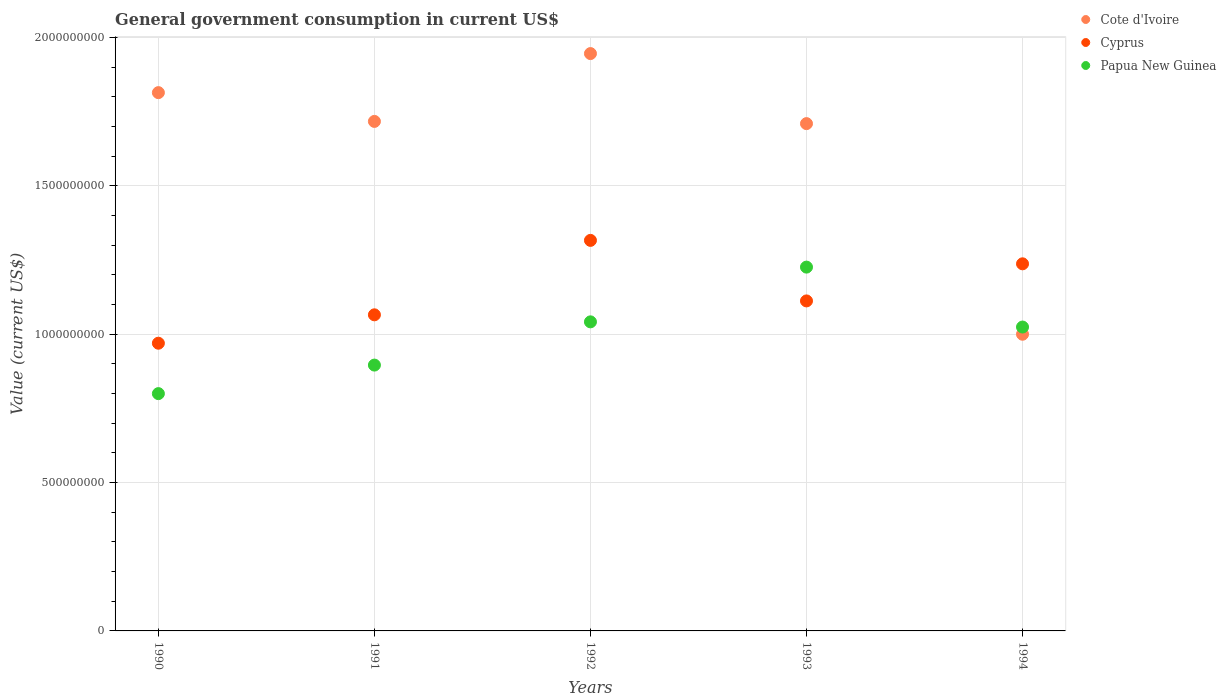How many different coloured dotlines are there?
Ensure brevity in your answer.  3. Is the number of dotlines equal to the number of legend labels?
Offer a terse response. Yes. What is the government conusmption in Papua New Guinea in 1991?
Provide a short and direct response. 8.96e+08. Across all years, what is the maximum government conusmption in Papua New Guinea?
Keep it short and to the point. 1.23e+09. Across all years, what is the minimum government conusmption in Cyprus?
Make the answer very short. 9.69e+08. What is the total government conusmption in Cote d'Ivoire in the graph?
Keep it short and to the point. 8.18e+09. What is the difference between the government conusmption in Cyprus in 1993 and that in 1994?
Your response must be concise. -1.25e+08. What is the difference between the government conusmption in Papua New Guinea in 1993 and the government conusmption in Cyprus in 1992?
Your answer should be very brief. -9.01e+07. What is the average government conusmption in Cote d'Ivoire per year?
Your answer should be very brief. 1.64e+09. In the year 1992, what is the difference between the government conusmption in Cote d'Ivoire and government conusmption in Cyprus?
Your answer should be compact. 6.29e+08. In how many years, is the government conusmption in Cote d'Ivoire greater than 800000000 US$?
Make the answer very short. 5. What is the ratio of the government conusmption in Papua New Guinea in 1990 to that in 1991?
Offer a terse response. 0.89. Is the government conusmption in Papua New Guinea in 1991 less than that in 1994?
Offer a terse response. Yes. What is the difference between the highest and the second highest government conusmption in Cote d'Ivoire?
Your answer should be compact. 1.32e+08. What is the difference between the highest and the lowest government conusmption in Papua New Guinea?
Make the answer very short. 4.26e+08. In how many years, is the government conusmption in Papua New Guinea greater than the average government conusmption in Papua New Guinea taken over all years?
Provide a succinct answer. 3. Is the sum of the government conusmption in Cyprus in 1990 and 1993 greater than the maximum government conusmption in Papua New Guinea across all years?
Provide a succinct answer. Yes. Is it the case that in every year, the sum of the government conusmption in Cyprus and government conusmption in Cote d'Ivoire  is greater than the government conusmption in Papua New Guinea?
Your answer should be compact. Yes. Is the government conusmption in Papua New Guinea strictly less than the government conusmption in Cote d'Ivoire over the years?
Keep it short and to the point. No. How many years are there in the graph?
Your answer should be compact. 5. Does the graph contain any zero values?
Your response must be concise. No. What is the title of the graph?
Your answer should be very brief. General government consumption in current US$. Does "French Polynesia" appear as one of the legend labels in the graph?
Offer a terse response. No. What is the label or title of the X-axis?
Ensure brevity in your answer.  Years. What is the label or title of the Y-axis?
Offer a terse response. Value (current US$). What is the Value (current US$) in Cote d'Ivoire in 1990?
Ensure brevity in your answer.  1.81e+09. What is the Value (current US$) in Cyprus in 1990?
Give a very brief answer. 9.69e+08. What is the Value (current US$) of Papua New Guinea in 1990?
Provide a short and direct response. 8.00e+08. What is the Value (current US$) in Cote d'Ivoire in 1991?
Provide a succinct answer. 1.72e+09. What is the Value (current US$) in Cyprus in 1991?
Your response must be concise. 1.07e+09. What is the Value (current US$) in Papua New Guinea in 1991?
Ensure brevity in your answer.  8.96e+08. What is the Value (current US$) in Cote d'Ivoire in 1992?
Your answer should be compact. 1.95e+09. What is the Value (current US$) in Cyprus in 1992?
Provide a succinct answer. 1.32e+09. What is the Value (current US$) in Papua New Guinea in 1992?
Keep it short and to the point. 1.04e+09. What is the Value (current US$) of Cote d'Ivoire in 1993?
Your answer should be very brief. 1.71e+09. What is the Value (current US$) in Cyprus in 1993?
Keep it short and to the point. 1.11e+09. What is the Value (current US$) of Papua New Guinea in 1993?
Provide a succinct answer. 1.23e+09. What is the Value (current US$) in Cote d'Ivoire in 1994?
Keep it short and to the point. 1.00e+09. What is the Value (current US$) in Cyprus in 1994?
Give a very brief answer. 1.24e+09. What is the Value (current US$) of Papua New Guinea in 1994?
Keep it short and to the point. 1.02e+09. Across all years, what is the maximum Value (current US$) in Cote d'Ivoire?
Keep it short and to the point. 1.95e+09. Across all years, what is the maximum Value (current US$) of Cyprus?
Your response must be concise. 1.32e+09. Across all years, what is the maximum Value (current US$) in Papua New Guinea?
Ensure brevity in your answer.  1.23e+09. Across all years, what is the minimum Value (current US$) in Cote d'Ivoire?
Keep it short and to the point. 1.00e+09. Across all years, what is the minimum Value (current US$) of Cyprus?
Keep it short and to the point. 9.69e+08. Across all years, what is the minimum Value (current US$) in Papua New Guinea?
Provide a succinct answer. 8.00e+08. What is the total Value (current US$) in Cote d'Ivoire in the graph?
Make the answer very short. 8.18e+09. What is the total Value (current US$) of Cyprus in the graph?
Provide a short and direct response. 5.70e+09. What is the total Value (current US$) in Papua New Guinea in the graph?
Your response must be concise. 4.99e+09. What is the difference between the Value (current US$) of Cote d'Ivoire in 1990 and that in 1991?
Provide a succinct answer. 9.70e+07. What is the difference between the Value (current US$) in Cyprus in 1990 and that in 1991?
Ensure brevity in your answer.  -9.57e+07. What is the difference between the Value (current US$) in Papua New Guinea in 1990 and that in 1991?
Your answer should be compact. -9.61e+07. What is the difference between the Value (current US$) of Cote d'Ivoire in 1990 and that in 1992?
Provide a short and direct response. -1.32e+08. What is the difference between the Value (current US$) in Cyprus in 1990 and that in 1992?
Your answer should be very brief. -3.46e+08. What is the difference between the Value (current US$) of Papua New Guinea in 1990 and that in 1992?
Provide a succinct answer. -2.42e+08. What is the difference between the Value (current US$) of Cote d'Ivoire in 1990 and that in 1993?
Your response must be concise. 1.04e+08. What is the difference between the Value (current US$) in Cyprus in 1990 and that in 1993?
Your answer should be very brief. -1.43e+08. What is the difference between the Value (current US$) of Papua New Guinea in 1990 and that in 1993?
Your answer should be compact. -4.26e+08. What is the difference between the Value (current US$) of Cote d'Ivoire in 1990 and that in 1994?
Your answer should be very brief. 8.14e+08. What is the difference between the Value (current US$) in Cyprus in 1990 and that in 1994?
Give a very brief answer. -2.68e+08. What is the difference between the Value (current US$) in Papua New Guinea in 1990 and that in 1994?
Your answer should be compact. -2.24e+08. What is the difference between the Value (current US$) in Cote d'Ivoire in 1991 and that in 1992?
Offer a very short reply. -2.29e+08. What is the difference between the Value (current US$) of Cyprus in 1991 and that in 1992?
Your answer should be compact. -2.51e+08. What is the difference between the Value (current US$) in Papua New Guinea in 1991 and that in 1992?
Your answer should be compact. -1.46e+08. What is the difference between the Value (current US$) of Cote d'Ivoire in 1991 and that in 1993?
Ensure brevity in your answer.  7.46e+06. What is the difference between the Value (current US$) in Cyprus in 1991 and that in 1993?
Offer a very short reply. -4.68e+07. What is the difference between the Value (current US$) of Papua New Guinea in 1991 and that in 1993?
Provide a short and direct response. -3.30e+08. What is the difference between the Value (current US$) of Cote d'Ivoire in 1991 and that in 1994?
Make the answer very short. 7.17e+08. What is the difference between the Value (current US$) in Cyprus in 1991 and that in 1994?
Offer a terse response. -1.72e+08. What is the difference between the Value (current US$) in Papua New Guinea in 1991 and that in 1994?
Ensure brevity in your answer.  -1.28e+08. What is the difference between the Value (current US$) of Cote d'Ivoire in 1992 and that in 1993?
Make the answer very short. 2.36e+08. What is the difference between the Value (current US$) in Cyprus in 1992 and that in 1993?
Provide a short and direct response. 2.04e+08. What is the difference between the Value (current US$) in Papua New Guinea in 1992 and that in 1993?
Your answer should be very brief. -1.84e+08. What is the difference between the Value (current US$) in Cote d'Ivoire in 1992 and that in 1994?
Offer a terse response. 9.46e+08. What is the difference between the Value (current US$) of Cyprus in 1992 and that in 1994?
Your response must be concise. 7.90e+07. What is the difference between the Value (current US$) of Papua New Guinea in 1992 and that in 1994?
Your answer should be very brief. 1.75e+07. What is the difference between the Value (current US$) of Cote d'Ivoire in 1993 and that in 1994?
Keep it short and to the point. 7.10e+08. What is the difference between the Value (current US$) of Cyprus in 1993 and that in 1994?
Give a very brief answer. -1.25e+08. What is the difference between the Value (current US$) in Papua New Guinea in 1993 and that in 1994?
Your answer should be compact. 2.02e+08. What is the difference between the Value (current US$) of Cote d'Ivoire in 1990 and the Value (current US$) of Cyprus in 1991?
Give a very brief answer. 7.49e+08. What is the difference between the Value (current US$) of Cote d'Ivoire in 1990 and the Value (current US$) of Papua New Guinea in 1991?
Ensure brevity in your answer.  9.18e+08. What is the difference between the Value (current US$) in Cyprus in 1990 and the Value (current US$) in Papua New Guinea in 1991?
Make the answer very short. 7.37e+07. What is the difference between the Value (current US$) of Cote d'Ivoire in 1990 and the Value (current US$) of Cyprus in 1992?
Your response must be concise. 4.98e+08. What is the difference between the Value (current US$) of Cote d'Ivoire in 1990 and the Value (current US$) of Papua New Guinea in 1992?
Provide a succinct answer. 7.72e+08. What is the difference between the Value (current US$) in Cyprus in 1990 and the Value (current US$) in Papua New Guinea in 1992?
Your answer should be compact. -7.20e+07. What is the difference between the Value (current US$) of Cote d'Ivoire in 1990 and the Value (current US$) of Cyprus in 1993?
Your response must be concise. 7.02e+08. What is the difference between the Value (current US$) of Cote d'Ivoire in 1990 and the Value (current US$) of Papua New Guinea in 1993?
Make the answer very short. 5.88e+08. What is the difference between the Value (current US$) in Cyprus in 1990 and the Value (current US$) in Papua New Guinea in 1993?
Offer a very short reply. -2.56e+08. What is the difference between the Value (current US$) in Cote d'Ivoire in 1990 and the Value (current US$) in Cyprus in 1994?
Give a very brief answer. 5.77e+08. What is the difference between the Value (current US$) in Cote d'Ivoire in 1990 and the Value (current US$) in Papua New Guinea in 1994?
Offer a terse response. 7.90e+08. What is the difference between the Value (current US$) of Cyprus in 1990 and the Value (current US$) of Papua New Guinea in 1994?
Provide a succinct answer. -5.45e+07. What is the difference between the Value (current US$) in Cote d'Ivoire in 1991 and the Value (current US$) in Cyprus in 1992?
Provide a succinct answer. 4.01e+08. What is the difference between the Value (current US$) in Cote d'Ivoire in 1991 and the Value (current US$) in Papua New Guinea in 1992?
Provide a succinct answer. 6.75e+08. What is the difference between the Value (current US$) in Cyprus in 1991 and the Value (current US$) in Papua New Guinea in 1992?
Your answer should be very brief. 2.37e+07. What is the difference between the Value (current US$) of Cote d'Ivoire in 1991 and the Value (current US$) of Cyprus in 1993?
Provide a succinct answer. 6.05e+08. What is the difference between the Value (current US$) in Cote d'Ivoire in 1991 and the Value (current US$) in Papua New Guinea in 1993?
Your response must be concise. 4.91e+08. What is the difference between the Value (current US$) in Cyprus in 1991 and the Value (current US$) in Papua New Guinea in 1993?
Your response must be concise. -1.61e+08. What is the difference between the Value (current US$) of Cote d'Ivoire in 1991 and the Value (current US$) of Cyprus in 1994?
Provide a short and direct response. 4.80e+08. What is the difference between the Value (current US$) in Cote d'Ivoire in 1991 and the Value (current US$) in Papua New Guinea in 1994?
Make the answer very short. 6.93e+08. What is the difference between the Value (current US$) of Cyprus in 1991 and the Value (current US$) of Papua New Guinea in 1994?
Make the answer very short. 4.12e+07. What is the difference between the Value (current US$) of Cote d'Ivoire in 1992 and the Value (current US$) of Cyprus in 1993?
Your answer should be compact. 8.33e+08. What is the difference between the Value (current US$) in Cote d'Ivoire in 1992 and the Value (current US$) in Papua New Guinea in 1993?
Provide a short and direct response. 7.19e+08. What is the difference between the Value (current US$) in Cyprus in 1992 and the Value (current US$) in Papua New Guinea in 1993?
Offer a terse response. 9.01e+07. What is the difference between the Value (current US$) in Cote d'Ivoire in 1992 and the Value (current US$) in Cyprus in 1994?
Offer a terse response. 7.08e+08. What is the difference between the Value (current US$) of Cote d'Ivoire in 1992 and the Value (current US$) of Papua New Guinea in 1994?
Offer a very short reply. 9.21e+08. What is the difference between the Value (current US$) of Cyprus in 1992 and the Value (current US$) of Papua New Guinea in 1994?
Your answer should be compact. 2.92e+08. What is the difference between the Value (current US$) in Cote d'Ivoire in 1993 and the Value (current US$) in Cyprus in 1994?
Ensure brevity in your answer.  4.72e+08. What is the difference between the Value (current US$) of Cote d'Ivoire in 1993 and the Value (current US$) of Papua New Guinea in 1994?
Keep it short and to the point. 6.85e+08. What is the difference between the Value (current US$) of Cyprus in 1993 and the Value (current US$) of Papua New Guinea in 1994?
Provide a succinct answer. 8.80e+07. What is the average Value (current US$) in Cote d'Ivoire per year?
Your answer should be very brief. 1.64e+09. What is the average Value (current US$) in Cyprus per year?
Provide a short and direct response. 1.14e+09. What is the average Value (current US$) in Papua New Guinea per year?
Your answer should be very brief. 9.97e+08. In the year 1990, what is the difference between the Value (current US$) of Cote d'Ivoire and Value (current US$) of Cyprus?
Give a very brief answer. 8.44e+08. In the year 1990, what is the difference between the Value (current US$) in Cote d'Ivoire and Value (current US$) in Papua New Guinea?
Your response must be concise. 1.01e+09. In the year 1990, what is the difference between the Value (current US$) of Cyprus and Value (current US$) of Papua New Guinea?
Provide a short and direct response. 1.70e+08. In the year 1991, what is the difference between the Value (current US$) of Cote d'Ivoire and Value (current US$) of Cyprus?
Make the answer very short. 6.52e+08. In the year 1991, what is the difference between the Value (current US$) in Cote d'Ivoire and Value (current US$) in Papua New Guinea?
Your answer should be very brief. 8.21e+08. In the year 1991, what is the difference between the Value (current US$) in Cyprus and Value (current US$) in Papua New Guinea?
Provide a succinct answer. 1.69e+08. In the year 1992, what is the difference between the Value (current US$) in Cote d'Ivoire and Value (current US$) in Cyprus?
Give a very brief answer. 6.29e+08. In the year 1992, what is the difference between the Value (current US$) of Cote d'Ivoire and Value (current US$) of Papua New Guinea?
Provide a short and direct response. 9.04e+08. In the year 1992, what is the difference between the Value (current US$) of Cyprus and Value (current US$) of Papua New Guinea?
Your answer should be compact. 2.75e+08. In the year 1993, what is the difference between the Value (current US$) in Cote d'Ivoire and Value (current US$) in Cyprus?
Your response must be concise. 5.97e+08. In the year 1993, what is the difference between the Value (current US$) in Cote d'Ivoire and Value (current US$) in Papua New Guinea?
Your response must be concise. 4.83e+08. In the year 1993, what is the difference between the Value (current US$) of Cyprus and Value (current US$) of Papua New Guinea?
Give a very brief answer. -1.14e+08. In the year 1994, what is the difference between the Value (current US$) of Cote d'Ivoire and Value (current US$) of Cyprus?
Provide a short and direct response. -2.37e+08. In the year 1994, what is the difference between the Value (current US$) of Cote d'Ivoire and Value (current US$) of Papua New Guinea?
Offer a very short reply. -2.43e+07. In the year 1994, what is the difference between the Value (current US$) of Cyprus and Value (current US$) of Papua New Guinea?
Your response must be concise. 2.13e+08. What is the ratio of the Value (current US$) in Cote d'Ivoire in 1990 to that in 1991?
Provide a succinct answer. 1.06. What is the ratio of the Value (current US$) in Cyprus in 1990 to that in 1991?
Ensure brevity in your answer.  0.91. What is the ratio of the Value (current US$) of Papua New Guinea in 1990 to that in 1991?
Your answer should be compact. 0.89. What is the ratio of the Value (current US$) in Cote d'Ivoire in 1990 to that in 1992?
Your response must be concise. 0.93. What is the ratio of the Value (current US$) of Cyprus in 1990 to that in 1992?
Provide a short and direct response. 0.74. What is the ratio of the Value (current US$) of Papua New Guinea in 1990 to that in 1992?
Give a very brief answer. 0.77. What is the ratio of the Value (current US$) in Cote d'Ivoire in 1990 to that in 1993?
Your response must be concise. 1.06. What is the ratio of the Value (current US$) in Cyprus in 1990 to that in 1993?
Keep it short and to the point. 0.87. What is the ratio of the Value (current US$) of Papua New Guinea in 1990 to that in 1993?
Keep it short and to the point. 0.65. What is the ratio of the Value (current US$) of Cote d'Ivoire in 1990 to that in 1994?
Offer a very short reply. 1.81. What is the ratio of the Value (current US$) in Cyprus in 1990 to that in 1994?
Provide a short and direct response. 0.78. What is the ratio of the Value (current US$) in Papua New Guinea in 1990 to that in 1994?
Make the answer very short. 0.78. What is the ratio of the Value (current US$) of Cote d'Ivoire in 1991 to that in 1992?
Give a very brief answer. 0.88. What is the ratio of the Value (current US$) in Cyprus in 1991 to that in 1992?
Give a very brief answer. 0.81. What is the ratio of the Value (current US$) in Papua New Guinea in 1991 to that in 1992?
Give a very brief answer. 0.86. What is the ratio of the Value (current US$) in Cyprus in 1991 to that in 1993?
Offer a terse response. 0.96. What is the ratio of the Value (current US$) in Papua New Guinea in 1991 to that in 1993?
Provide a short and direct response. 0.73. What is the ratio of the Value (current US$) in Cote d'Ivoire in 1991 to that in 1994?
Offer a very short reply. 1.72. What is the ratio of the Value (current US$) of Cyprus in 1991 to that in 1994?
Make the answer very short. 0.86. What is the ratio of the Value (current US$) in Papua New Guinea in 1991 to that in 1994?
Provide a short and direct response. 0.87. What is the ratio of the Value (current US$) of Cote d'Ivoire in 1992 to that in 1993?
Make the answer very short. 1.14. What is the ratio of the Value (current US$) of Cyprus in 1992 to that in 1993?
Your answer should be compact. 1.18. What is the ratio of the Value (current US$) of Papua New Guinea in 1992 to that in 1993?
Your answer should be very brief. 0.85. What is the ratio of the Value (current US$) in Cote d'Ivoire in 1992 to that in 1994?
Offer a very short reply. 1.95. What is the ratio of the Value (current US$) in Cyprus in 1992 to that in 1994?
Keep it short and to the point. 1.06. What is the ratio of the Value (current US$) in Papua New Guinea in 1992 to that in 1994?
Keep it short and to the point. 1.02. What is the ratio of the Value (current US$) of Cote d'Ivoire in 1993 to that in 1994?
Give a very brief answer. 1.71. What is the ratio of the Value (current US$) in Cyprus in 1993 to that in 1994?
Ensure brevity in your answer.  0.9. What is the ratio of the Value (current US$) in Papua New Guinea in 1993 to that in 1994?
Keep it short and to the point. 1.2. What is the difference between the highest and the second highest Value (current US$) in Cote d'Ivoire?
Provide a short and direct response. 1.32e+08. What is the difference between the highest and the second highest Value (current US$) in Cyprus?
Your answer should be very brief. 7.90e+07. What is the difference between the highest and the second highest Value (current US$) in Papua New Guinea?
Offer a terse response. 1.84e+08. What is the difference between the highest and the lowest Value (current US$) in Cote d'Ivoire?
Your answer should be compact. 9.46e+08. What is the difference between the highest and the lowest Value (current US$) of Cyprus?
Give a very brief answer. 3.46e+08. What is the difference between the highest and the lowest Value (current US$) of Papua New Guinea?
Provide a short and direct response. 4.26e+08. 